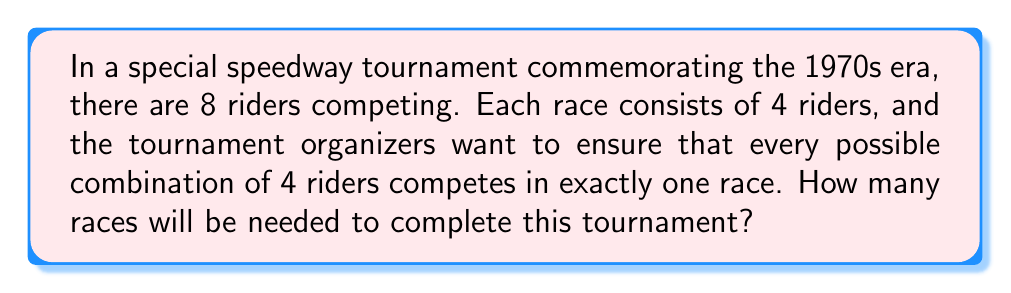Solve this math problem. To solve this problem, we need to use combinatorics, specifically the concept of combinations. Let's break it down step-by-step:

1) We are selecting 4 riders from a total of 8 riders for each race.

2) The order of selection doesn't matter (the riders' positions on the starting gate are determined separately), so we use combinations rather than permutations.

3) We need to calculate the number of ways to choose 4 riders from 8, which is denoted as $\binom{8}{4}$ or $C(8,4)$.

4) The formula for this combination is:

   $$\binom{8}{4} = \frac{8!}{4!(8-4)!} = \frac{8!}{4!4!}$$

5) Let's calculate this:
   
   $$\frac{8 \cdot 7 \cdot 6 \cdot 5 \cdot 4!}{(4 \cdot 3 \cdot 2 \cdot 1) \cdot 4!}$$

6) The 4! cancels out in the numerator and denominator:

   $$\frac{8 \cdot 7 \cdot 6 \cdot 5}{4 \cdot 3 \cdot 2 \cdot 1} = \frac{1680}{24} = 70$$

Therefore, 70 different races are needed to ensure that every possible combination of 4 riders competes exactly once.
Answer: 70 races 